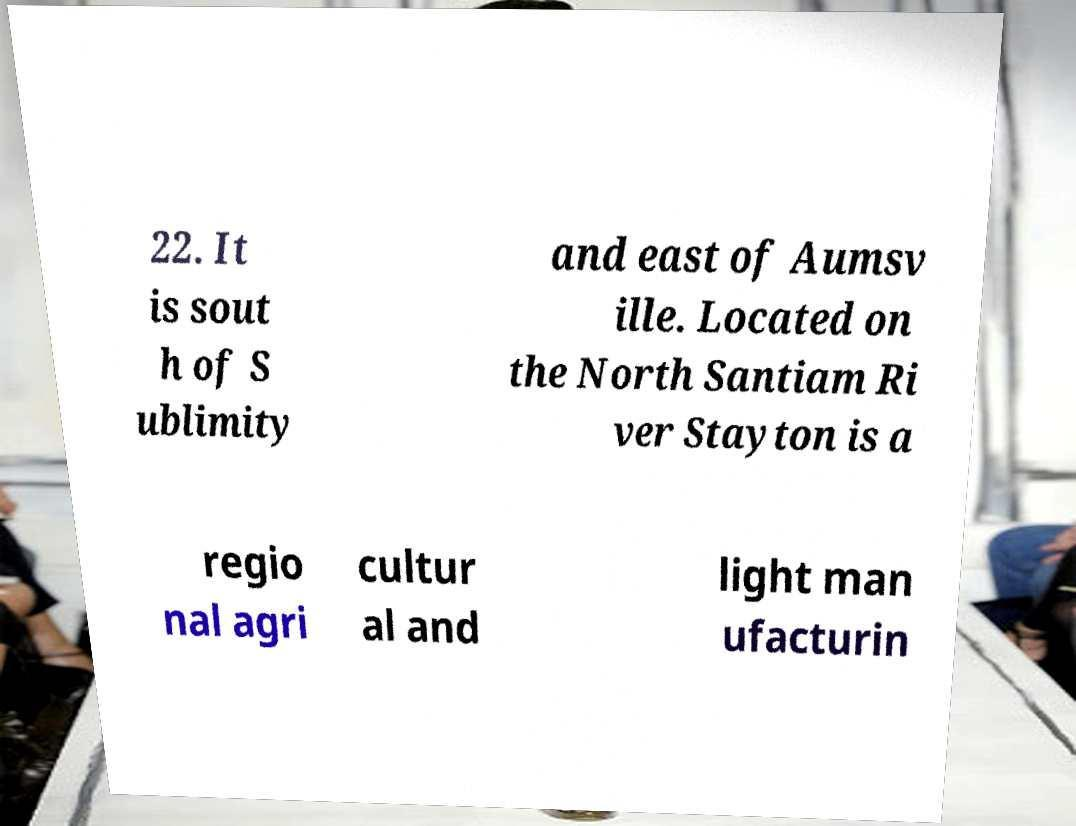Please identify and transcribe the text found in this image. 22. It is sout h of S ublimity and east of Aumsv ille. Located on the North Santiam Ri ver Stayton is a regio nal agri cultur al and light man ufacturin 